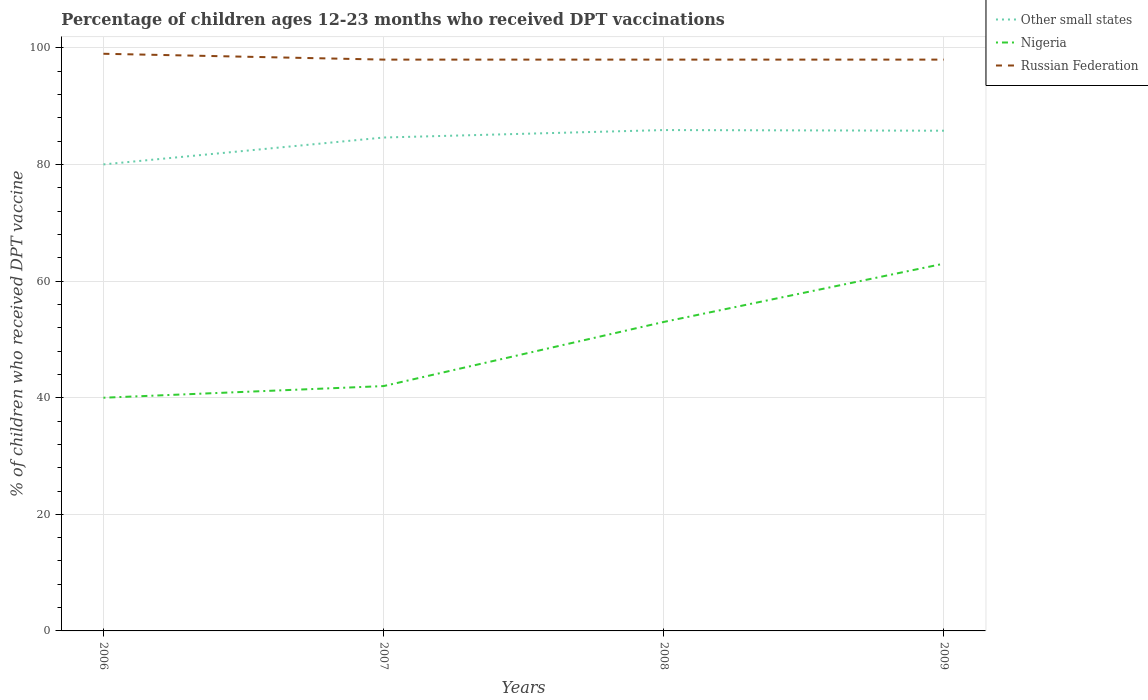How many different coloured lines are there?
Ensure brevity in your answer.  3. Across all years, what is the maximum percentage of children who received DPT vaccination in Other small states?
Ensure brevity in your answer.  80.02. What is the total percentage of children who received DPT vaccination in Other small states in the graph?
Your response must be concise. -1.28. What is the difference between the highest and the lowest percentage of children who received DPT vaccination in Nigeria?
Provide a short and direct response. 2. Is the percentage of children who received DPT vaccination in Other small states strictly greater than the percentage of children who received DPT vaccination in Russian Federation over the years?
Your response must be concise. Yes. How many lines are there?
Your answer should be compact. 3. How many years are there in the graph?
Make the answer very short. 4. Are the values on the major ticks of Y-axis written in scientific E-notation?
Give a very brief answer. No. Does the graph contain grids?
Provide a short and direct response. Yes. How are the legend labels stacked?
Your answer should be very brief. Vertical. What is the title of the graph?
Keep it short and to the point. Percentage of children ages 12-23 months who received DPT vaccinations. Does "Kazakhstan" appear as one of the legend labels in the graph?
Your answer should be compact. No. What is the label or title of the Y-axis?
Ensure brevity in your answer.  % of children who received DPT vaccine. What is the % of children who received DPT vaccine in Other small states in 2006?
Ensure brevity in your answer.  80.02. What is the % of children who received DPT vaccine in Nigeria in 2006?
Make the answer very short. 40. What is the % of children who received DPT vaccine of Russian Federation in 2006?
Give a very brief answer. 99. What is the % of children who received DPT vaccine of Other small states in 2007?
Your answer should be compact. 84.64. What is the % of children who received DPT vaccine in Nigeria in 2007?
Give a very brief answer. 42. What is the % of children who received DPT vaccine of Other small states in 2008?
Ensure brevity in your answer.  85.91. What is the % of children who received DPT vaccine in Other small states in 2009?
Give a very brief answer. 85.8. What is the % of children who received DPT vaccine of Nigeria in 2009?
Provide a short and direct response. 63. What is the % of children who received DPT vaccine of Russian Federation in 2009?
Make the answer very short. 98. Across all years, what is the maximum % of children who received DPT vaccine of Other small states?
Provide a succinct answer. 85.91. Across all years, what is the minimum % of children who received DPT vaccine of Other small states?
Give a very brief answer. 80.02. Across all years, what is the minimum % of children who received DPT vaccine in Nigeria?
Keep it short and to the point. 40. What is the total % of children who received DPT vaccine in Other small states in the graph?
Keep it short and to the point. 336.37. What is the total % of children who received DPT vaccine of Nigeria in the graph?
Provide a short and direct response. 198. What is the total % of children who received DPT vaccine in Russian Federation in the graph?
Provide a succinct answer. 393. What is the difference between the % of children who received DPT vaccine of Other small states in 2006 and that in 2007?
Provide a short and direct response. -4.61. What is the difference between the % of children who received DPT vaccine of Nigeria in 2006 and that in 2007?
Give a very brief answer. -2. What is the difference between the % of children who received DPT vaccine in Russian Federation in 2006 and that in 2007?
Your answer should be compact. 1. What is the difference between the % of children who received DPT vaccine in Other small states in 2006 and that in 2008?
Your answer should be compact. -5.89. What is the difference between the % of children who received DPT vaccine in Nigeria in 2006 and that in 2008?
Your response must be concise. -13. What is the difference between the % of children who received DPT vaccine in Other small states in 2006 and that in 2009?
Offer a terse response. -5.78. What is the difference between the % of children who received DPT vaccine in Nigeria in 2006 and that in 2009?
Provide a succinct answer. -23. What is the difference between the % of children who received DPT vaccine of Russian Federation in 2006 and that in 2009?
Your response must be concise. 1. What is the difference between the % of children who received DPT vaccine of Other small states in 2007 and that in 2008?
Keep it short and to the point. -1.28. What is the difference between the % of children who received DPT vaccine in Other small states in 2007 and that in 2009?
Give a very brief answer. -1.17. What is the difference between the % of children who received DPT vaccine in Russian Federation in 2007 and that in 2009?
Offer a terse response. 0. What is the difference between the % of children who received DPT vaccine in Other small states in 2008 and that in 2009?
Your response must be concise. 0.11. What is the difference between the % of children who received DPT vaccine in Russian Federation in 2008 and that in 2009?
Make the answer very short. 0. What is the difference between the % of children who received DPT vaccine in Other small states in 2006 and the % of children who received DPT vaccine in Nigeria in 2007?
Ensure brevity in your answer.  38.02. What is the difference between the % of children who received DPT vaccine of Other small states in 2006 and the % of children who received DPT vaccine of Russian Federation in 2007?
Make the answer very short. -17.98. What is the difference between the % of children who received DPT vaccine in Nigeria in 2006 and the % of children who received DPT vaccine in Russian Federation in 2007?
Your answer should be very brief. -58. What is the difference between the % of children who received DPT vaccine of Other small states in 2006 and the % of children who received DPT vaccine of Nigeria in 2008?
Provide a succinct answer. 27.02. What is the difference between the % of children who received DPT vaccine of Other small states in 2006 and the % of children who received DPT vaccine of Russian Federation in 2008?
Your answer should be compact. -17.98. What is the difference between the % of children who received DPT vaccine of Nigeria in 2006 and the % of children who received DPT vaccine of Russian Federation in 2008?
Your answer should be very brief. -58. What is the difference between the % of children who received DPT vaccine in Other small states in 2006 and the % of children who received DPT vaccine in Nigeria in 2009?
Ensure brevity in your answer.  17.02. What is the difference between the % of children who received DPT vaccine in Other small states in 2006 and the % of children who received DPT vaccine in Russian Federation in 2009?
Keep it short and to the point. -17.98. What is the difference between the % of children who received DPT vaccine of Nigeria in 2006 and the % of children who received DPT vaccine of Russian Federation in 2009?
Ensure brevity in your answer.  -58. What is the difference between the % of children who received DPT vaccine in Other small states in 2007 and the % of children who received DPT vaccine in Nigeria in 2008?
Keep it short and to the point. 31.64. What is the difference between the % of children who received DPT vaccine in Other small states in 2007 and the % of children who received DPT vaccine in Russian Federation in 2008?
Offer a terse response. -13.37. What is the difference between the % of children who received DPT vaccine of Nigeria in 2007 and the % of children who received DPT vaccine of Russian Federation in 2008?
Provide a succinct answer. -56. What is the difference between the % of children who received DPT vaccine in Other small states in 2007 and the % of children who received DPT vaccine in Nigeria in 2009?
Your answer should be compact. 21.64. What is the difference between the % of children who received DPT vaccine in Other small states in 2007 and the % of children who received DPT vaccine in Russian Federation in 2009?
Make the answer very short. -13.37. What is the difference between the % of children who received DPT vaccine in Nigeria in 2007 and the % of children who received DPT vaccine in Russian Federation in 2009?
Offer a very short reply. -56. What is the difference between the % of children who received DPT vaccine in Other small states in 2008 and the % of children who received DPT vaccine in Nigeria in 2009?
Your answer should be very brief. 22.91. What is the difference between the % of children who received DPT vaccine of Other small states in 2008 and the % of children who received DPT vaccine of Russian Federation in 2009?
Make the answer very short. -12.09. What is the difference between the % of children who received DPT vaccine in Nigeria in 2008 and the % of children who received DPT vaccine in Russian Federation in 2009?
Provide a short and direct response. -45. What is the average % of children who received DPT vaccine of Other small states per year?
Make the answer very short. 84.09. What is the average % of children who received DPT vaccine in Nigeria per year?
Provide a succinct answer. 49.5. What is the average % of children who received DPT vaccine of Russian Federation per year?
Give a very brief answer. 98.25. In the year 2006, what is the difference between the % of children who received DPT vaccine in Other small states and % of children who received DPT vaccine in Nigeria?
Give a very brief answer. 40.02. In the year 2006, what is the difference between the % of children who received DPT vaccine of Other small states and % of children who received DPT vaccine of Russian Federation?
Keep it short and to the point. -18.98. In the year 2006, what is the difference between the % of children who received DPT vaccine of Nigeria and % of children who received DPT vaccine of Russian Federation?
Your answer should be very brief. -59. In the year 2007, what is the difference between the % of children who received DPT vaccine in Other small states and % of children who received DPT vaccine in Nigeria?
Provide a succinct answer. 42.63. In the year 2007, what is the difference between the % of children who received DPT vaccine in Other small states and % of children who received DPT vaccine in Russian Federation?
Your answer should be compact. -13.37. In the year 2007, what is the difference between the % of children who received DPT vaccine of Nigeria and % of children who received DPT vaccine of Russian Federation?
Your answer should be compact. -56. In the year 2008, what is the difference between the % of children who received DPT vaccine in Other small states and % of children who received DPT vaccine in Nigeria?
Offer a very short reply. 32.91. In the year 2008, what is the difference between the % of children who received DPT vaccine in Other small states and % of children who received DPT vaccine in Russian Federation?
Provide a short and direct response. -12.09. In the year 2008, what is the difference between the % of children who received DPT vaccine in Nigeria and % of children who received DPT vaccine in Russian Federation?
Your answer should be very brief. -45. In the year 2009, what is the difference between the % of children who received DPT vaccine of Other small states and % of children who received DPT vaccine of Nigeria?
Keep it short and to the point. 22.8. In the year 2009, what is the difference between the % of children who received DPT vaccine in Other small states and % of children who received DPT vaccine in Russian Federation?
Keep it short and to the point. -12.2. In the year 2009, what is the difference between the % of children who received DPT vaccine of Nigeria and % of children who received DPT vaccine of Russian Federation?
Ensure brevity in your answer.  -35. What is the ratio of the % of children who received DPT vaccine in Other small states in 2006 to that in 2007?
Give a very brief answer. 0.95. What is the ratio of the % of children who received DPT vaccine of Russian Federation in 2006 to that in 2007?
Give a very brief answer. 1.01. What is the ratio of the % of children who received DPT vaccine in Other small states in 2006 to that in 2008?
Provide a succinct answer. 0.93. What is the ratio of the % of children who received DPT vaccine of Nigeria in 2006 to that in 2008?
Your response must be concise. 0.75. What is the ratio of the % of children who received DPT vaccine of Russian Federation in 2006 to that in 2008?
Give a very brief answer. 1.01. What is the ratio of the % of children who received DPT vaccine of Other small states in 2006 to that in 2009?
Your answer should be compact. 0.93. What is the ratio of the % of children who received DPT vaccine of Nigeria in 2006 to that in 2009?
Provide a short and direct response. 0.63. What is the ratio of the % of children who received DPT vaccine in Russian Federation in 2006 to that in 2009?
Your answer should be very brief. 1.01. What is the ratio of the % of children who received DPT vaccine in Other small states in 2007 to that in 2008?
Offer a terse response. 0.99. What is the ratio of the % of children who received DPT vaccine in Nigeria in 2007 to that in 2008?
Provide a succinct answer. 0.79. What is the ratio of the % of children who received DPT vaccine of Russian Federation in 2007 to that in 2008?
Your answer should be compact. 1. What is the ratio of the % of children who received DPT vaccine of Other small states in 2007 to that in 2009?
Your answer should be compact. 0.99. What is the ratio of the % of children who received DPT vaccine of Russian Federation in 2007 to that in 2009?
Keep it short and to the point. 1. What is the ratio of the % of children who received DPT vaccine of Nigeria in 2008 to that in 2009?
Offer a terse response. 0.84. What is the difference between the highest and the second highest % of children who received DPT vaccine in Other small states?
Your response must be concise. 0.11. What is the difference between the highest and the second highest % of children who received DPT vaccine of Nigeria?
Provide a succinct answer. 10. What is the difference between the highest and the lowest % of children who received DPT vaccine in Other small states?
Ensure brevity in your answer.  5.89. 